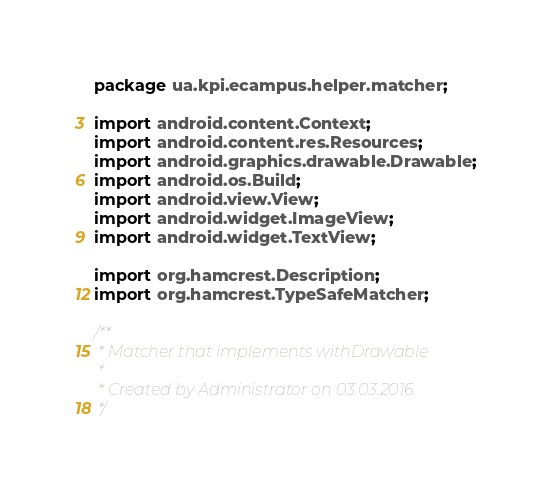Convert code to text. <code><loc_0><loc_0><loc_500><loc_500><_Java_>package ua.kpi.ecampus.helper.matcher;

import android.content.Context;
import android.content.res.Resources;
import android.graphics.drawable.Drawable;
import android.os.Build;
import android.view.View;
import android.widget.ImageView;
import android.widget.TextView;

import org.hamcrest.Description;
import org.hamcrest.TypeSafeMatcher;

/**
 * Matcher that implements withDrawable
 *
 * Created by Administrator on 03.03.2016.
 */</code> 